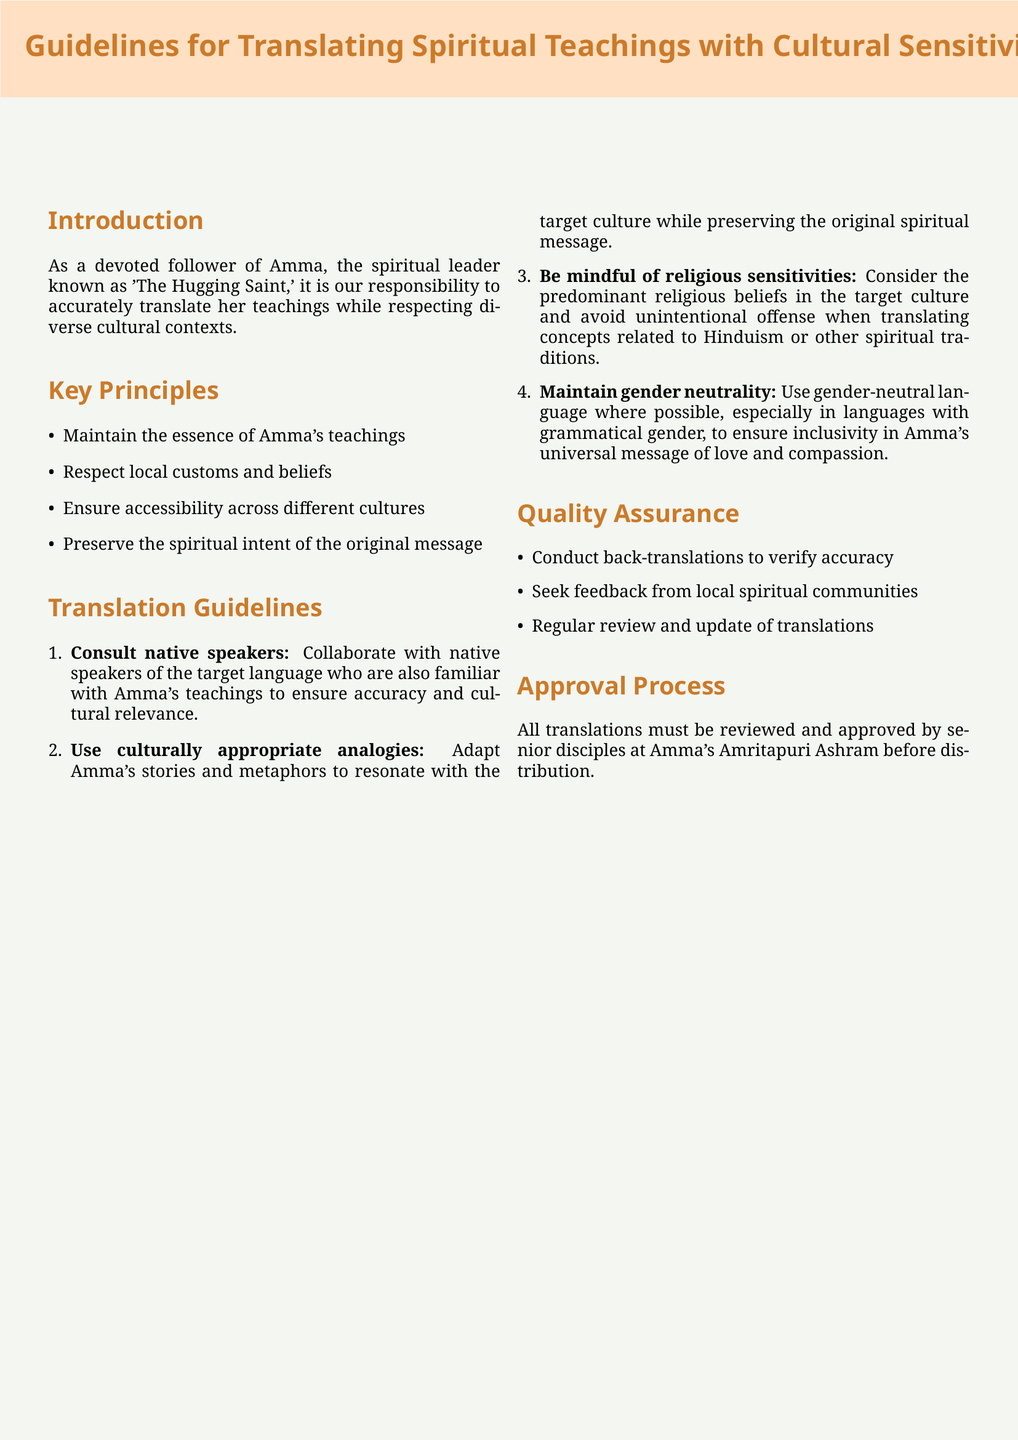What are the key principles of translation? The key principles listed in the document emphasize the essence of Amma's teachings, respect for local customs, accessibility, and preservation of spiritual intent.
Answer: Maintain the essence of Amma's teachings, respect local customs and beliefs, ensure accessibility across different cultures, preserve the spiritual intent of the original message Who must review and approve translations? The document specifies that senior disciples at Amma's Amritapuri Ashram are responsible for the review and approval of translations.
Answer: Senior disciples at Amma's Amritapuri Ashram How many guidelines are listed in the Translation Guidelines section? The document outlines a series of guidelines that explicitly enumerate the points to be followed for effective translation.
Answer: Four What is the purpose of conducting back-translations? The back-translation process is designed to verify the accuracy of translations, ensuring the integrity of the teaching.
Answer: To verify accuracy What should translators use to resonate with the target culture? The document emphasizes the importance of adapting narratives to fit cultural contexts while still conveying the essential message.
Answer: Culturally appropriate analogies Which language type should the translations aim to maintain? The document highlights the importance of inclusivity in the translations concerning gender, particularly in languages with grammatical gender.
Answer: Gender neutrality 